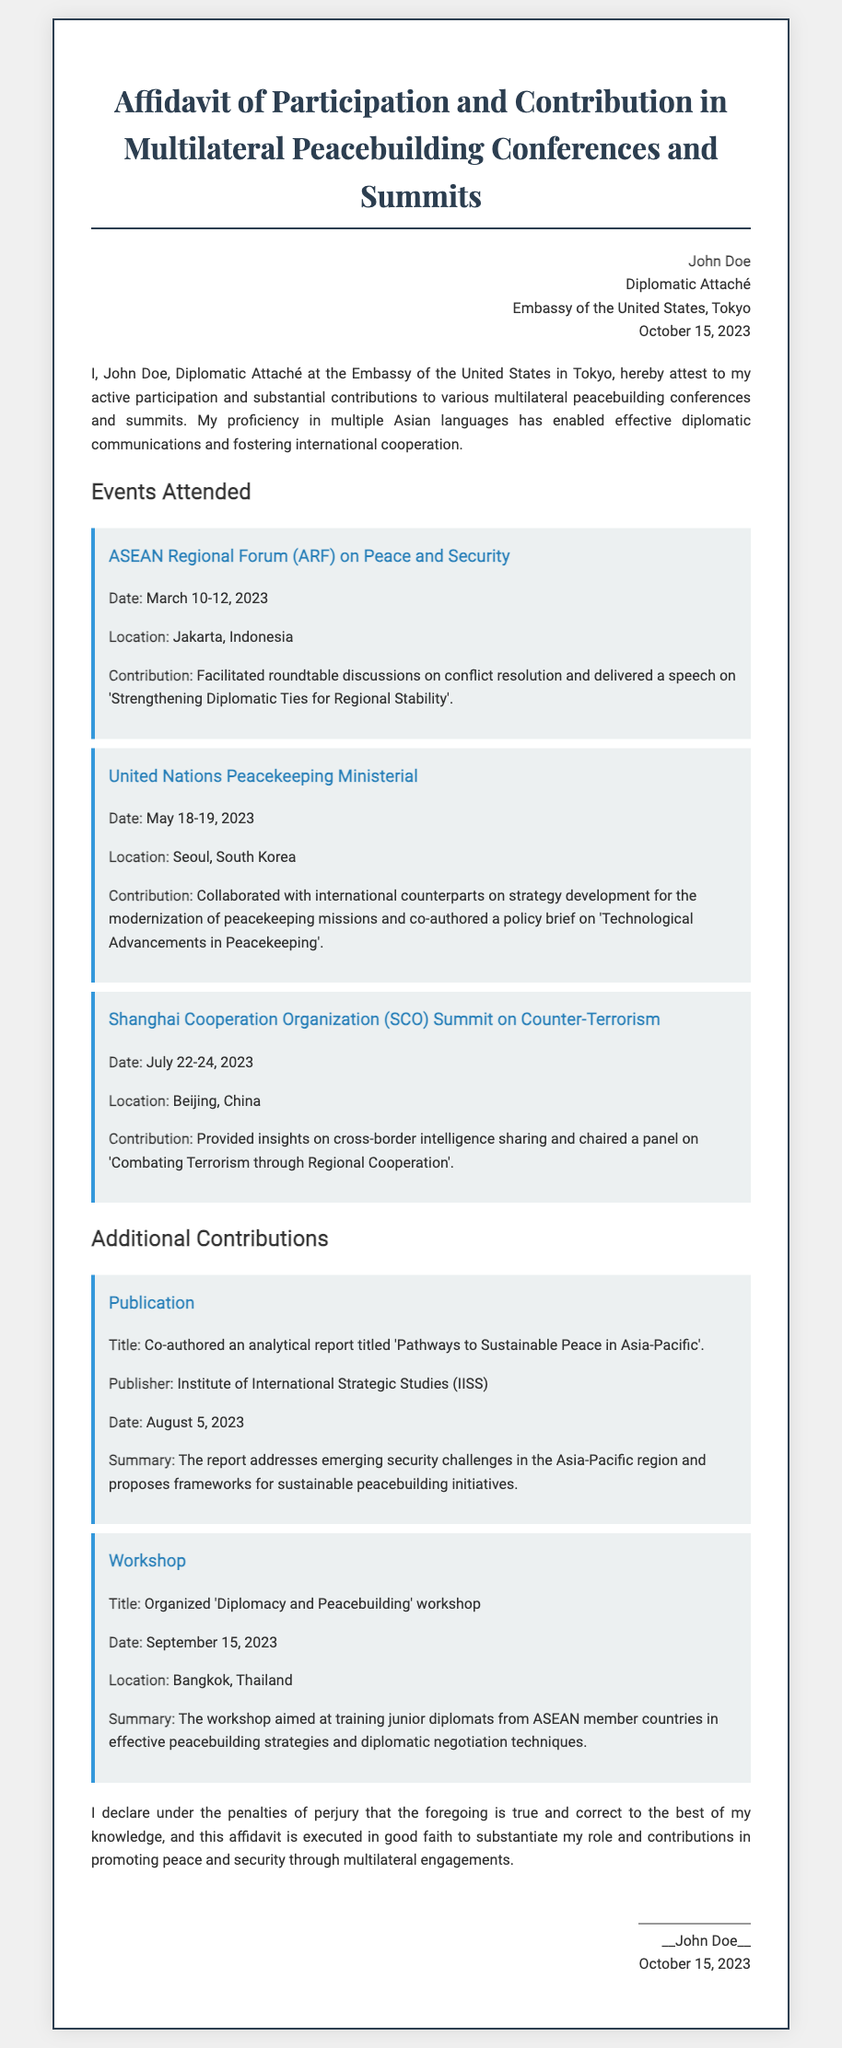What is the name of the individual attesting in the affidavit? The affidavit states that John Doe is the individual attesting.
Answer: John Doe When was the affidavit signed? The affidavit specifies the date of signing is October 15, 2023.
Answer: October 15, 2023 What is the location of the ASEAN Regional Forum event? The document mentions that it took place in Jakarta, Indonesia.
Answer: Jakarta, Indonesia What was the main topic of John Doe's speech at the ARF? The affidavit indicates the speech delivered was on "Strengthening Diplomatic Ties for Regional Stability."
Answer: Strengthening Diplomatic Ties for Regional Stability What report did John Doe co-author? The affidavit lists the title as "Pathways to Sustainable Peace in Asia-Pacific."
Answer: Pathways to Sustainable Peace in Asia-Pacific How many events are listed under "Events Attended"? The document details three events attended by John Doe.
Answer: Three What is the purpose of the "Diplomacy and Peacebuilding" workshop? The affidavit describes the workshop as aimed at training junior diplomats in peacebuilding strategies.
Answer: Training junior diplomats Which organization published the analytical report? The affidavit states that the report was published by the Institute of International Strategic Studies.
Answer: Institute of International Strategic Studies What is the signature format at the end of the affidavit? The affidavit concludes with John Doe's name followed by the date.
Answer: John Doe, October 15, 2023 